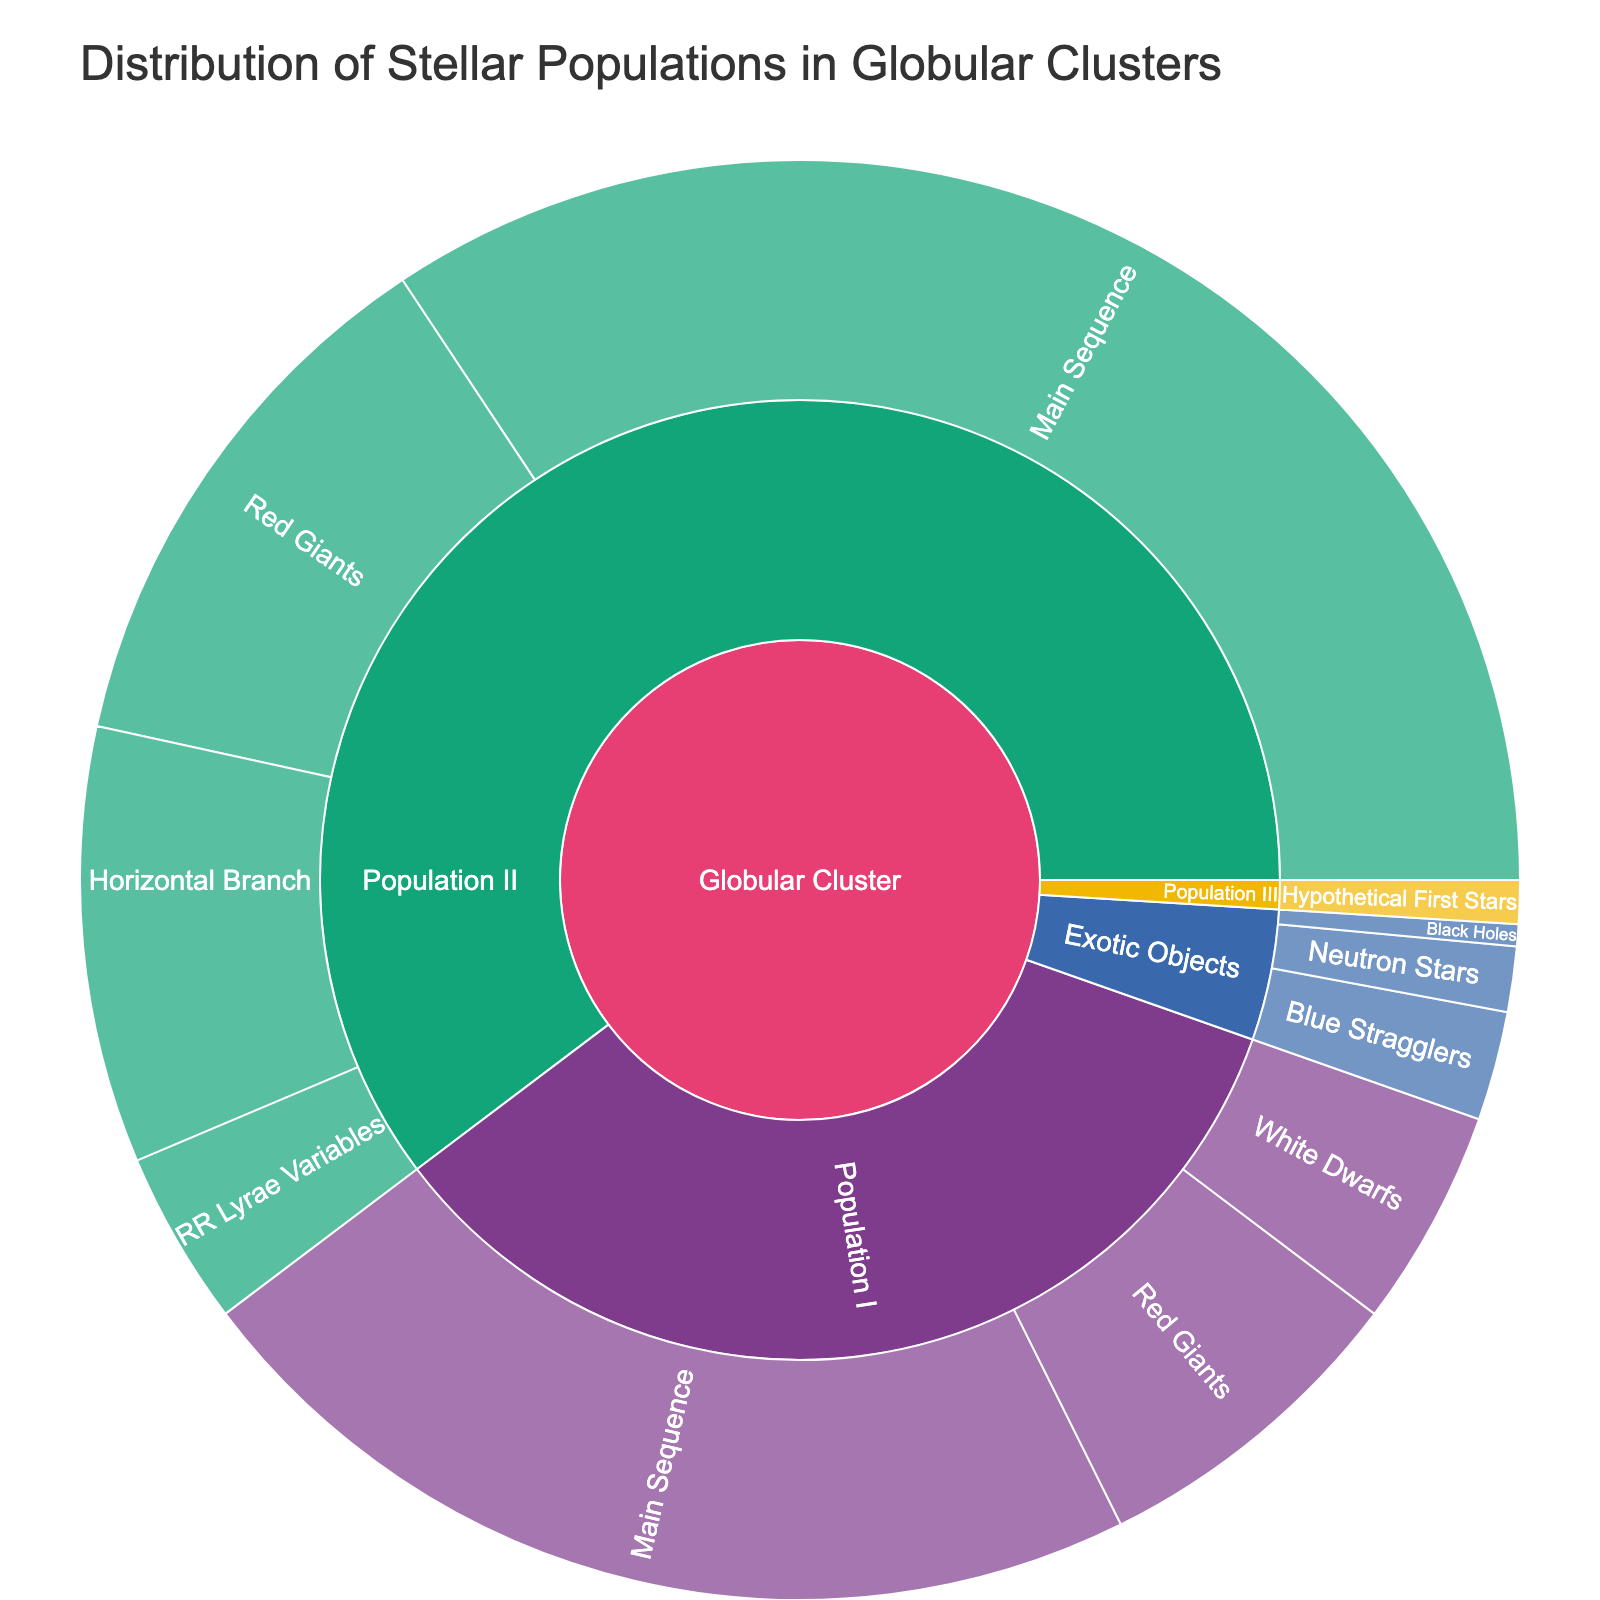What's the title of the figure? The title of the figure is typically positioned at the top of the plot and is clearly labeled. In this case, the title is specified as 'Distribution of Stellar Populations in Globular Clusters'.
Answer: Distribution of Stellar Populations in Globular Clusters Which population has the largest number of Main Sequence stars? First, identify the Main Sequence stars in both Population I and Population II. Population I has 45 Main Sequence stars, and Population II has 70 Main Sequence stars. Since 70 is greater than 45, Population II has more Main Sequence stars.
Answer: Population II How many Red Giants are there in total? Add the number of Red Giants in Population I (15) and Population II (25). The total is 15 + 25 = 40.
Answer: 40 Which category has the smallest number of objects? Examine each category: Population I, Population II, Population III, and Exotic Objects. Population III has the smallest number with only 2 objects (Hypothetical First Stars).
Answer: Population III What is the percentage of Horizontal Branch stars in Population II? Horizontal Branch stars in Population II are 20. The total number of stars in Population II (70 Main Sequence + 25 Red Giants + 20 Horizontal Branch + 8 RR Lyrae Variables) is 123. The percentage is (20/123) * 100 ≈ 16.3%.
Answer: 16.3% How do the numbers of Blue Stragglers and Neutron Stars in Exotic Objects compare? In Exotic Objects, there are 5 Blue Stragglers and 3 Neutron Stars. Since 5 is greater than 3, there are more Blue Stragglers than Neutron Stars.
Answer: More Blue Stragglers than Neutron Stars How many more Main Sequence stars are there in Population II compared to Population I? Population II has 70 Main Sequence stars and Population I has 45. The difference is 70 - 45 = 25.
Answer: 25 What is the combined number of White Dwarfs and Black Holes? The number of White Dwarfs is 10 and the number of Black Holes is 1. Their combined number is 10 + 1 = 11.
Answer: 11 Among the Exotic Objects, which type has the least amount? Examine each type in Exotic Objects: Blue Stragglers (5), Neutron Stars (3), and Black Holes (1). Black Holes have the least amount with 1.
Answer: Black Holes 